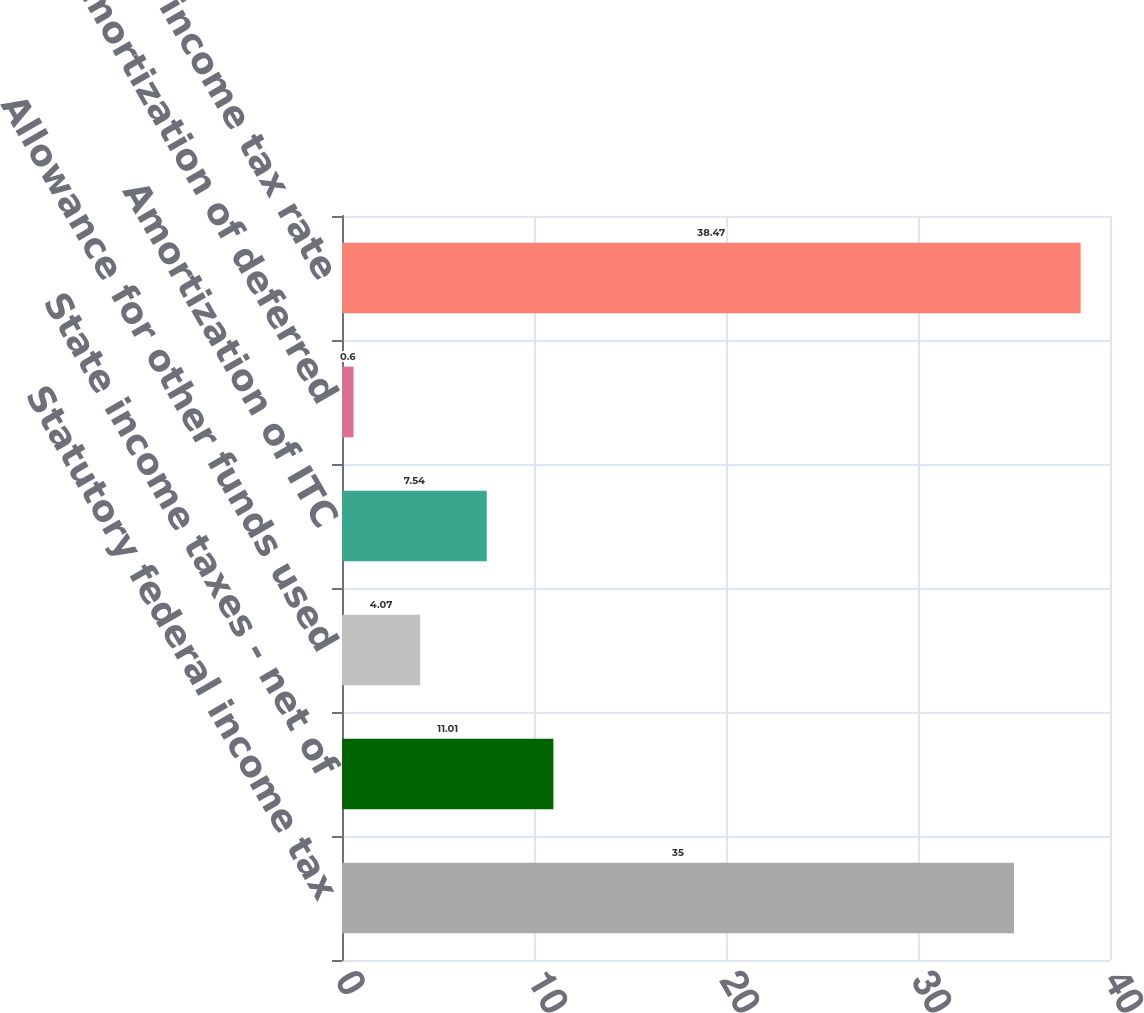<chart> <loc_0><loc_0><loc_500><loc_500><bar_chart><fcel>Statutory federal income tax<fcel>State income taxes - net of<fcel>Allowance for other funds used<fcel>Amortization of ITC<fcel>Amortization of deferred<fcel>Effective income tax rate<nl><fcel>35<fcel>11.01<fcel>4.07<fcel>7.54<fcel>0.6<fcel>38.47<nl></chart> 